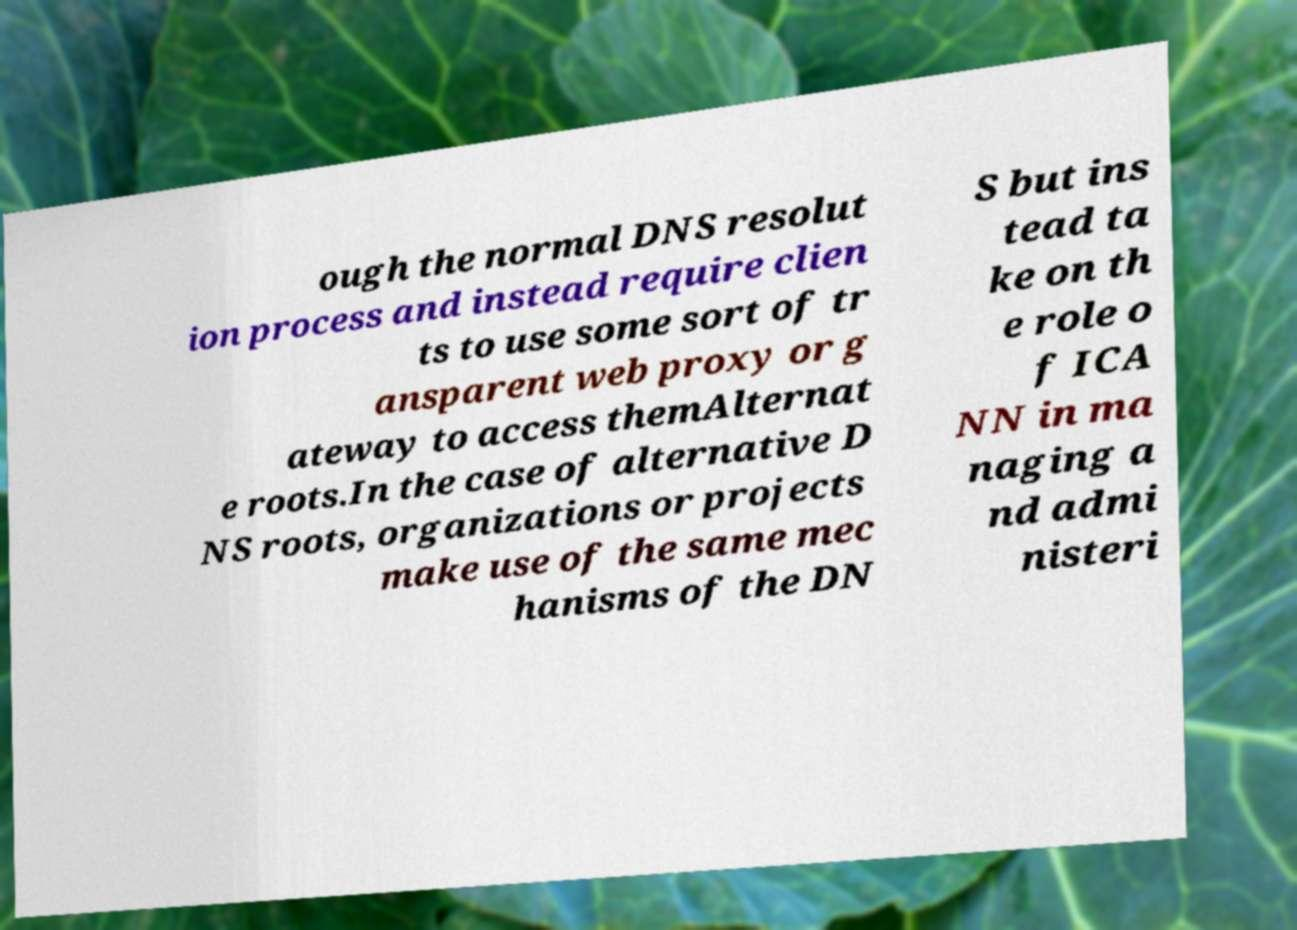Please read and relay the text visible in this image. What does it say? ough the normal DNS resolut ion process and instead require clien ts to use some sort of tr ansparent web proxy or g ateway to access themAlternat e roots.In the case of alternative D NS roots, organizations or projects make use of the same mec hanisms of the DN S but ins tead ta ke on th e role o f ICA NN in ma naging a nd admi nisteri 